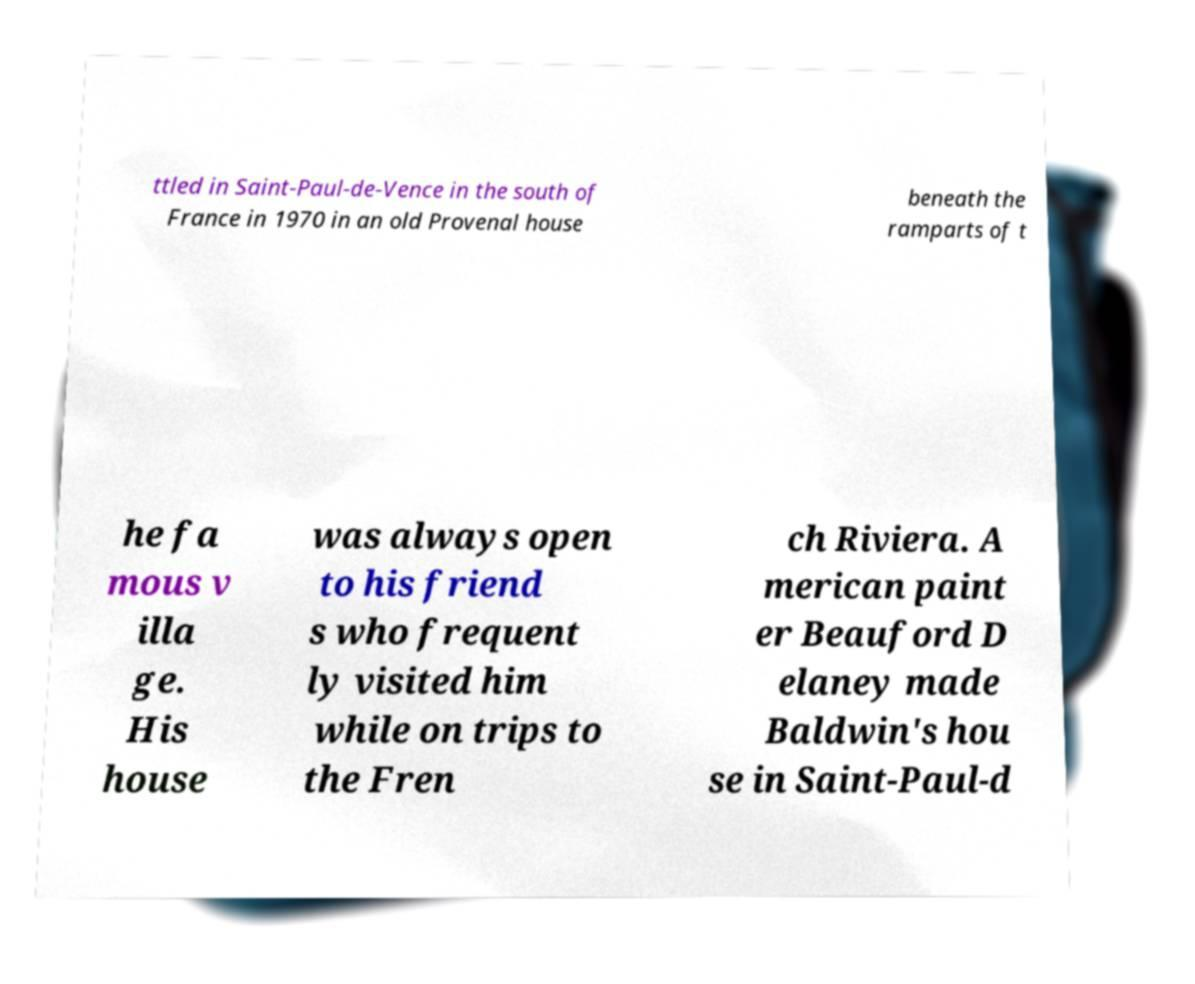I need the written content from this picture converted into text. Can you do that? ttled in Saint-Paul-de-Vence in the south of France in 1970 in an old Provenal house beneath the ramparts of t he fa mous v illa ge. His house was always open to his friend s who frequent ly visited him while on trips to the Fren ch Riviera. A merican paint er Beauford D elaney made Baldwin's hou se in Saint-Paul-d 